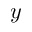<formula> <loc_0><loc_0><loc_500><loc_500>y</formula> 